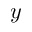<formula> <loc_0><loc_0><loc_500><loc_500>y</formula> 